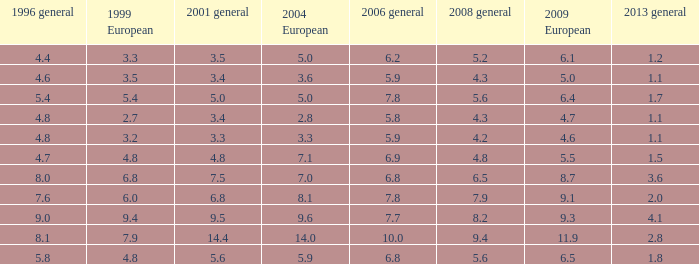4 in 1996 overall? None. 